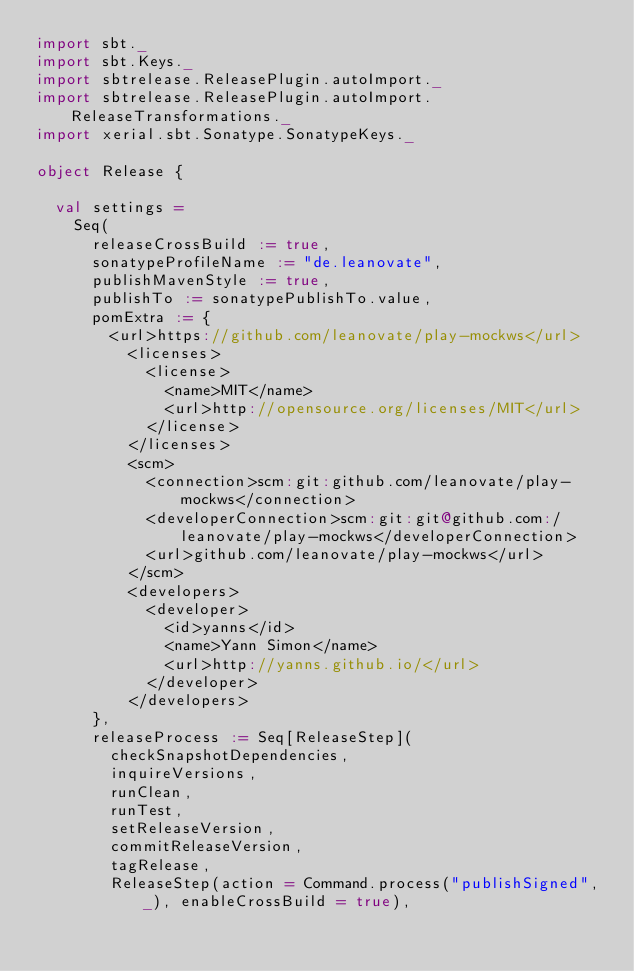Convert code to text. <code><loc_0><loc_0><loc_500><loc_500><_Scala_>import sbt._
import sbt.Keys._
import sbtrelease.ReleasePlugin.autoImport._
import sbtrelease.ReleasePlugin.autoImport.ReleaseTransformations._
import xerial.sbt.Sonatype.SonatypeKeys._

object Release {

  val settings =
    Seq(
      releaseCrossBuild := true,
      sonatypeProfileName := "de.leanovate",
      publishMavenStyle := true,
      publishTo := sonatypePublishTo.value,
      pomExtra := {
        <url>https://github.com/leanovate/play-mockws</url>
          <licenses>
            <license>
              <name>MIT</name>
              <url>http://opensource.org/licenses/MIT</url>
            </license>
          </licenses>
          <scm>
            <connection>scm:git:github.com/leanovate/play-mockws</connection>
            <developerConnection>scm:git:git@github.com:/leanovate/play-mockws</developerConnection>
            <url>github.com/leanovate/play-mockws</url>
          </scm>
          <developers>
            <developer>
              <id>yanns</id>
              <name>Yann Simon</name>
              <url>http://yanns.github.io/</url>
            </developer>
          </developers>
      },
      releaseProcess := Seq[ReleaseStep](
        checkSnapshotDependencies,
        inquireVersions,
        runClean,
        runTest,
        setReleaseVersion,
        commitReleaseVersion,
        tagRelease,
        ReleaseStep(action = Command.process("publishSigned", _), enableCrossBuild = true),</code> 